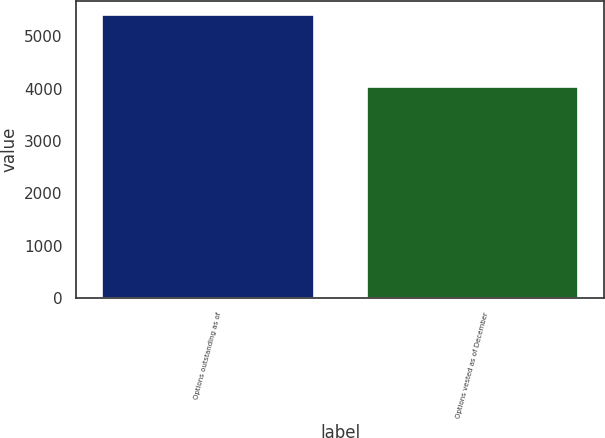Convert chart to OTSL. <chart><loc_0><loc_0><loc_500><loc_500><bar_chart><fcel>Options outstanding as of<fcel>Options vested as of December<nl><fcel>5414<fcel>4029<nl></chart> 